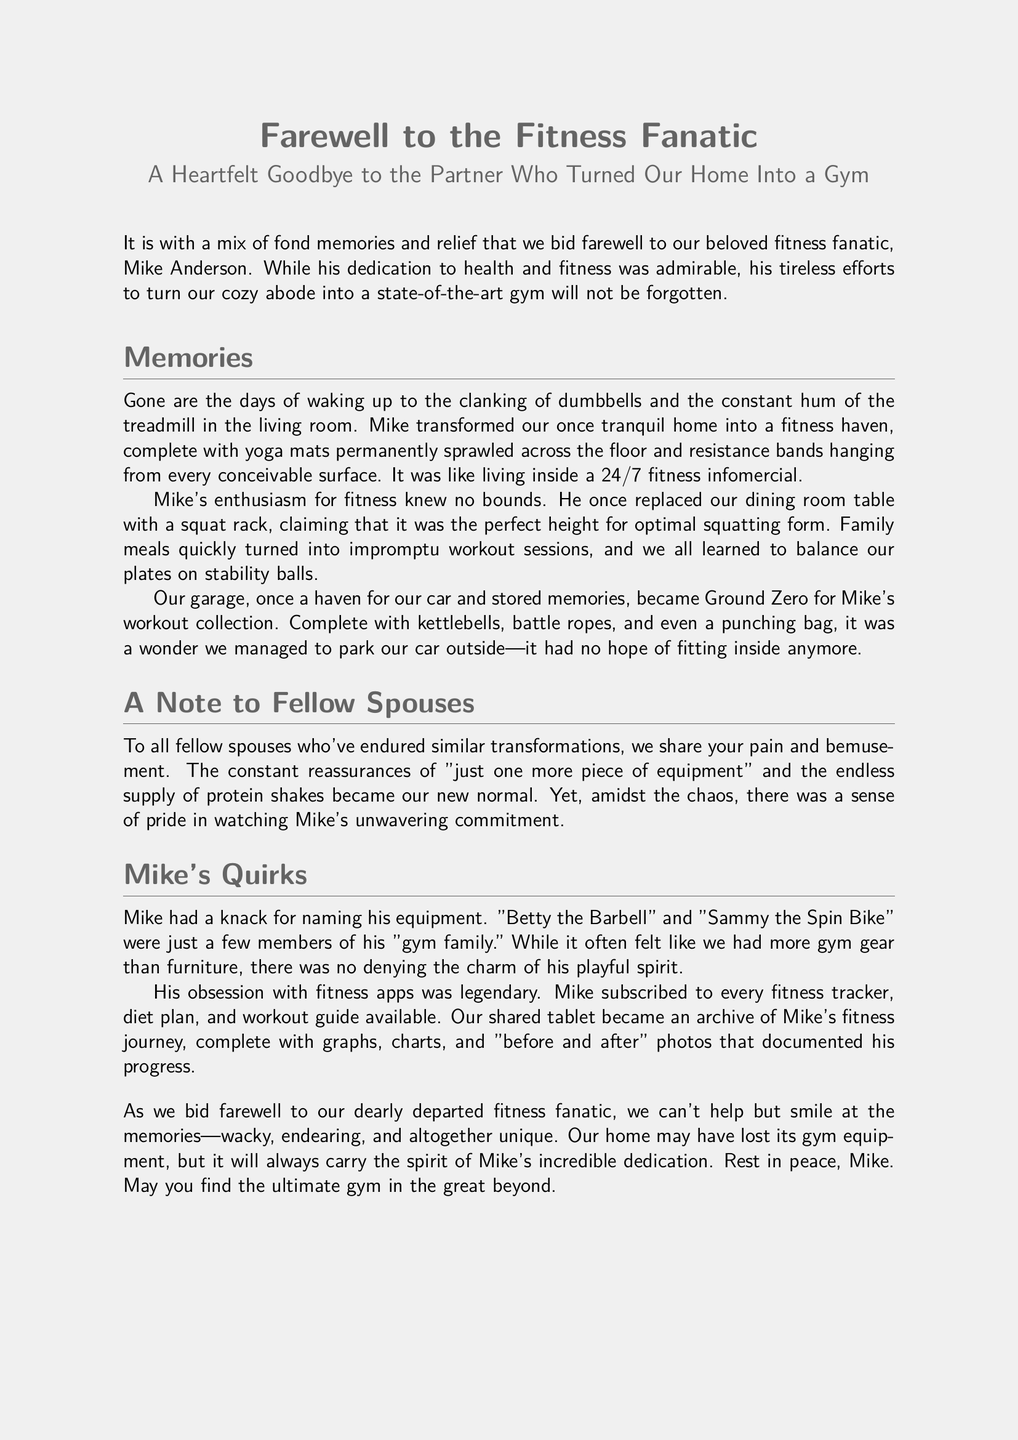What is the name of the fitness fanatic? The document mentions Mike Anderson as the fitness fanatic.
Answer: Mike Anderson What did Mike replace the dining room table with? The document states that Mike replaced the dining room table with a squat rack.
Answer: Squat rack What kind of spirit did Mike have according to the obituary? The obituary describes Mike's spirit as playful, particularly in how he named his gym equipment.
Answer: Playful What was the ultimate gym mentioned in the conclusion? The document refers to the "great beyond" as the ultimate gym Mike may have found.
Answer: Great beyond What equipment did Mike name "Betty"? The document specifies that Mike named his barbell "Betty."
Answer: Barbell How did family meals change according to the document? The document indicates that family meals turned into impromptu workout sessions.
Answer: Impromptu workout sessions How many fitness trackers and apps did Mike subscribe to? The document describes Mike's obsession with every fitness tracker available, suggesting there were many subscriptions.
Answer: Every fitness tracker What was the nickname given to the spin bike? The document mentions that the spin bike was named "Sammy."
Answer: Sammy What characterized the home environment transformed by Mike's fitness obsession? The document details how the home was turned into a fitness haven.
Answer: Fitness haven 